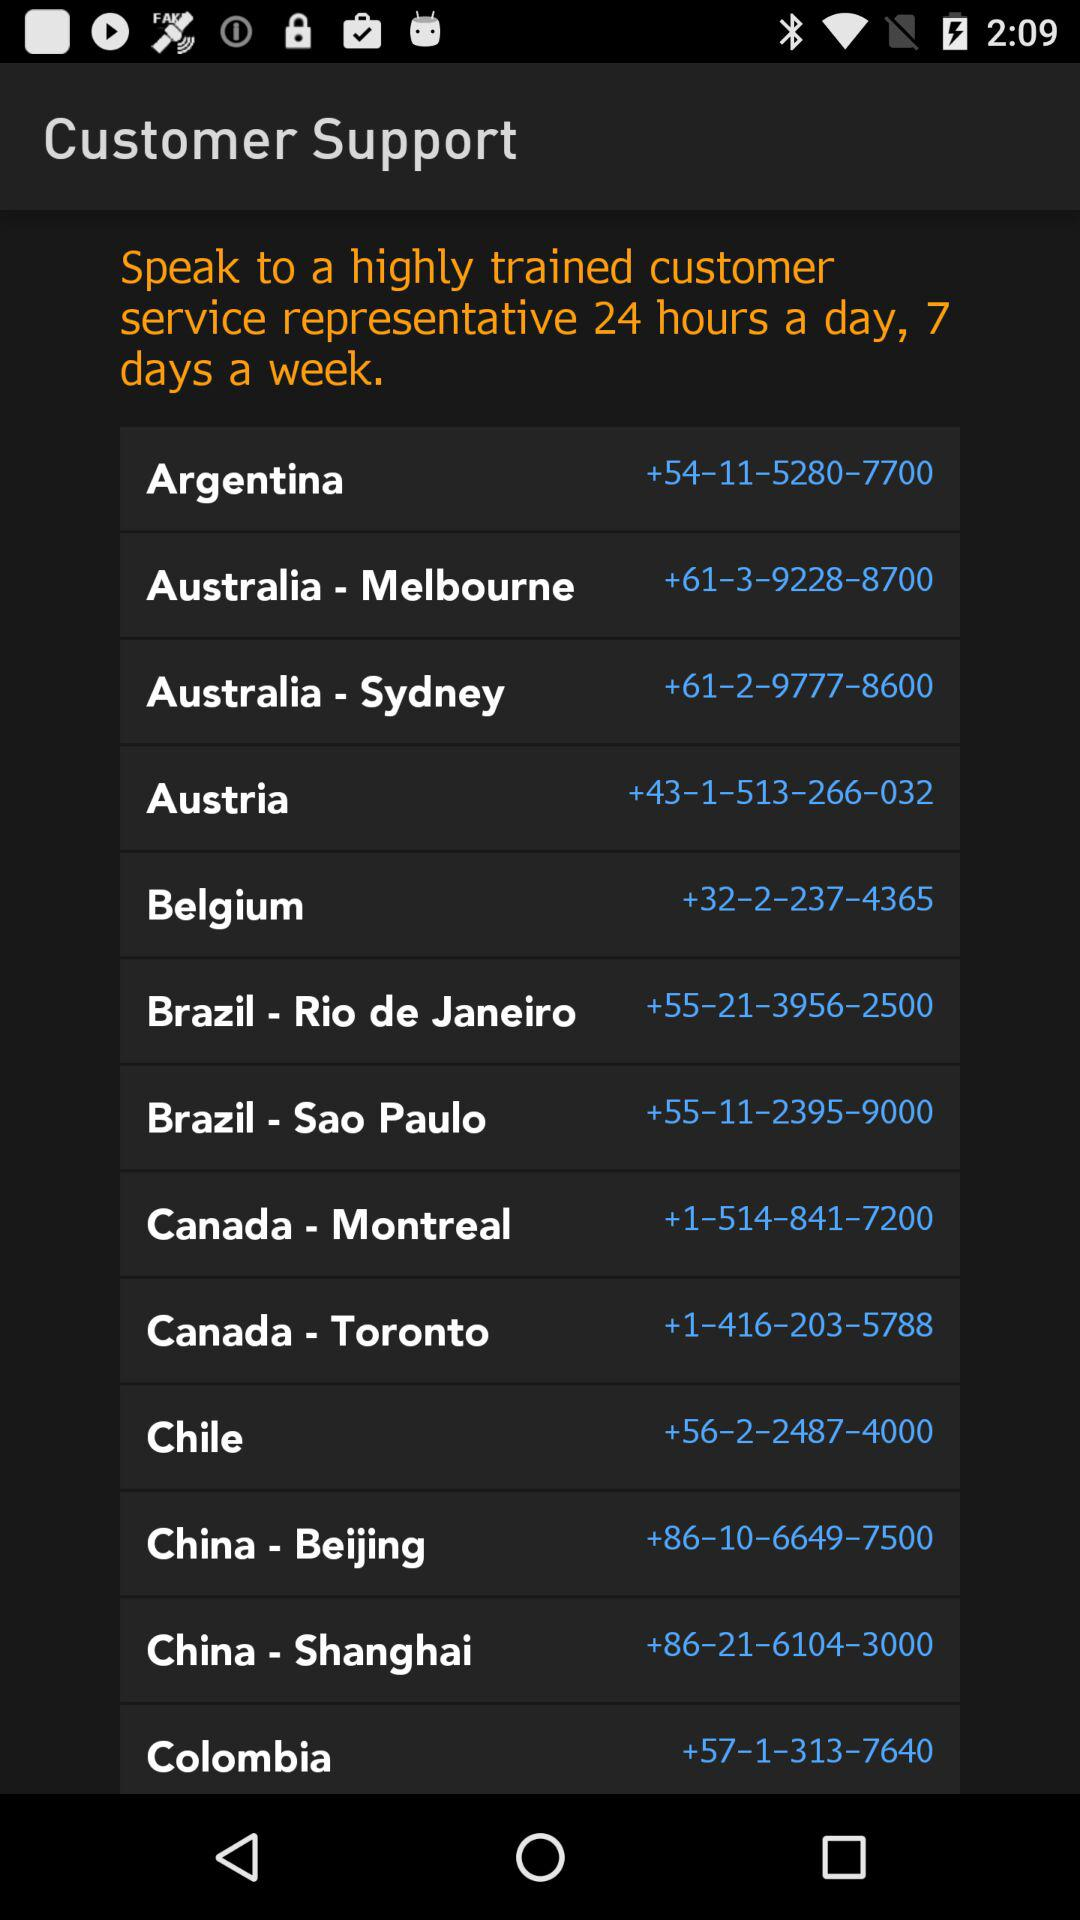Who is available to support customers for 24 hours? To support customers for 24 hours, the customer service representative is available. 